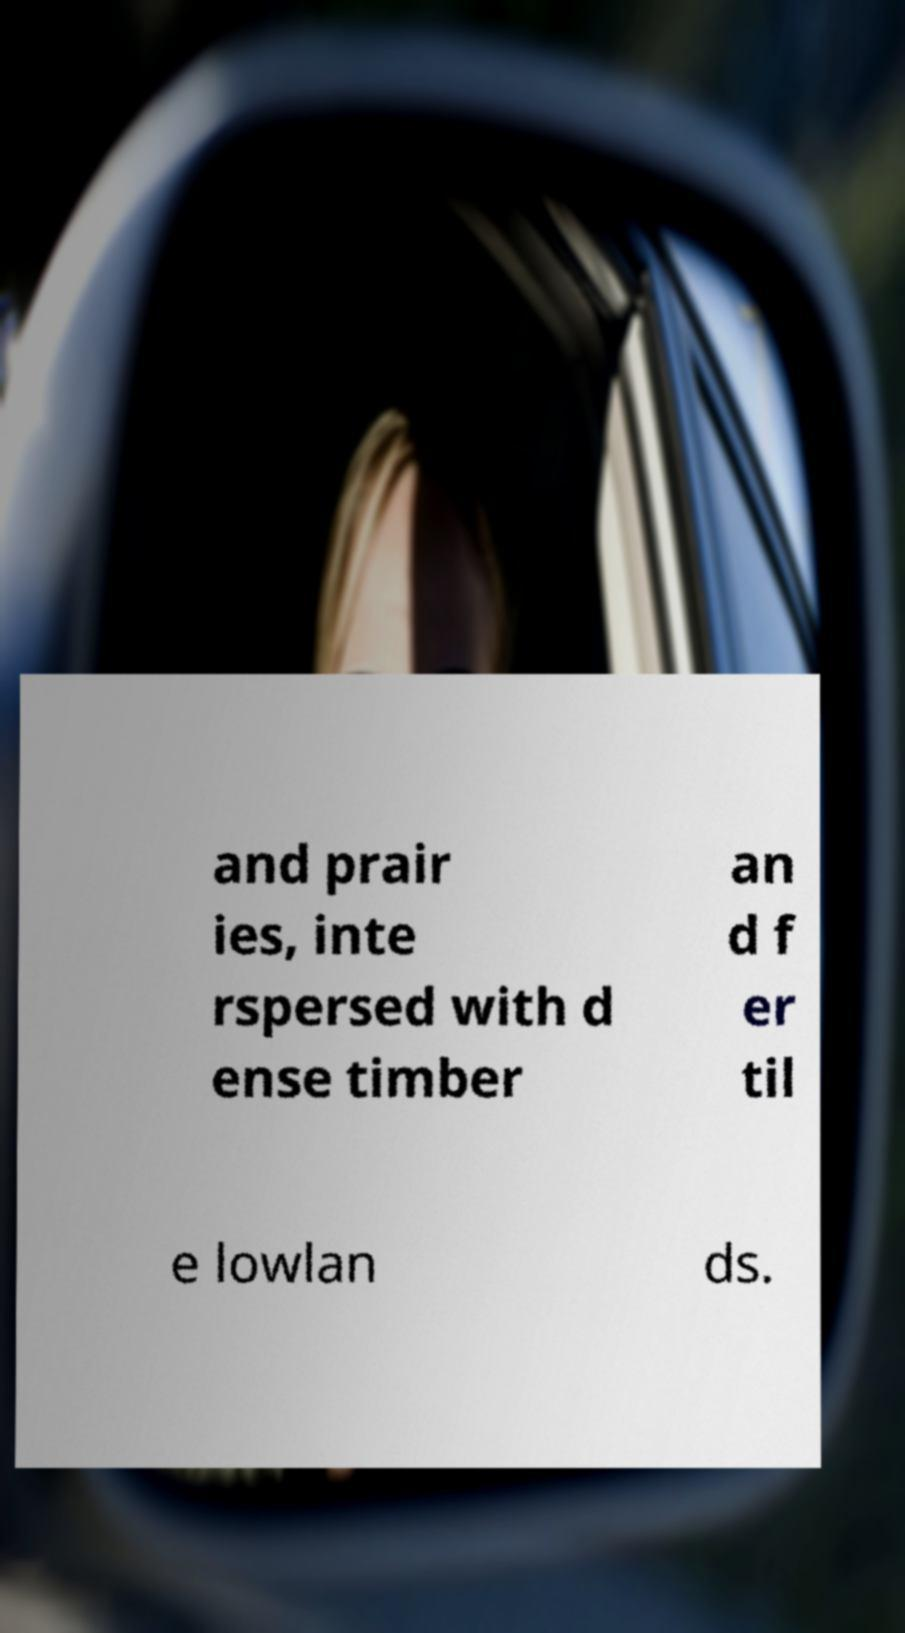Could you extract and type out the text from this image? and prair ies, inte rspersed with d ense timber an d f er til e lowlan ds. 